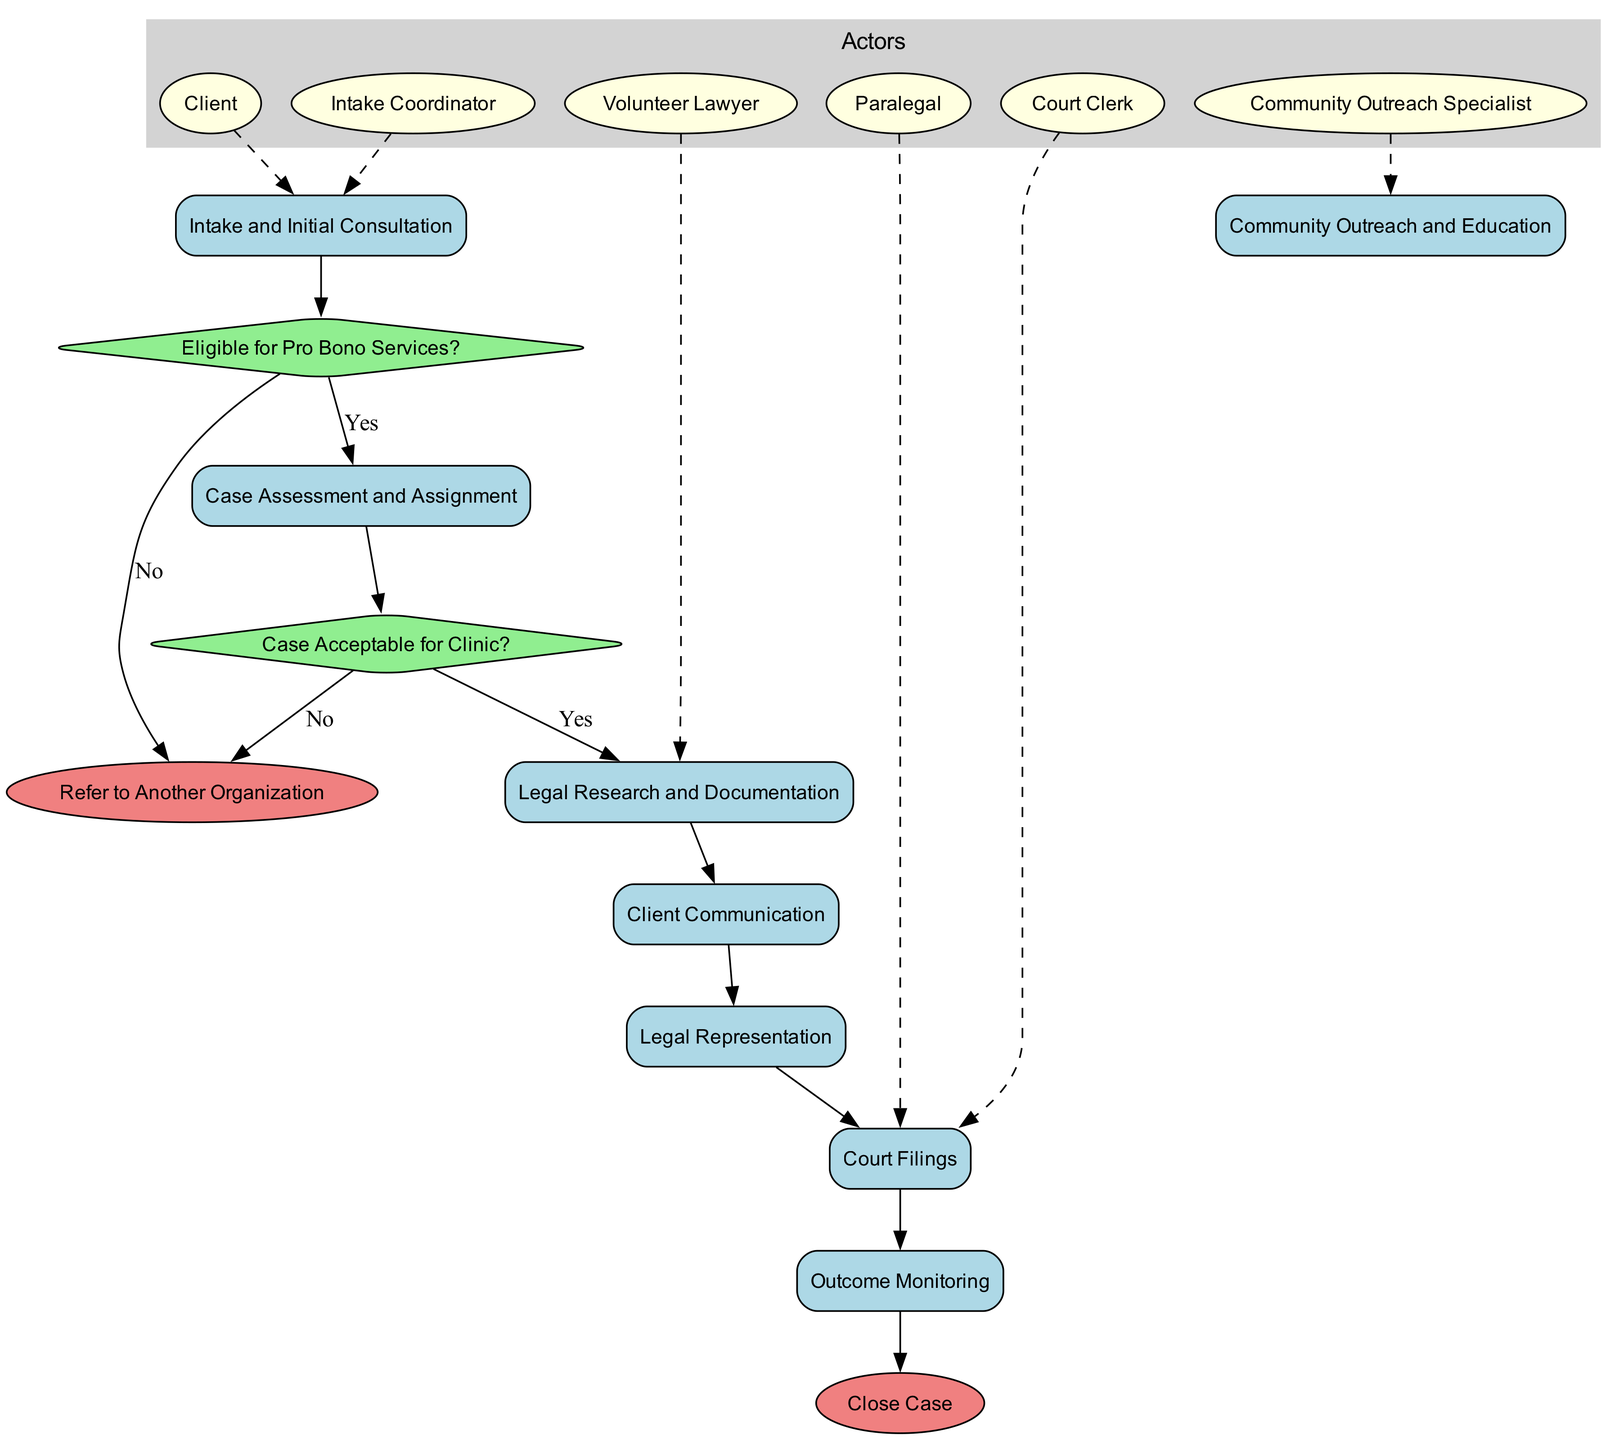What is the first activity in the diagram? The diagram lists "Intake and Initial Consultation" as the first activity, which is linked to the decision on eligibility for pro bono services.
Answer: Intake and Initial Consultation How many activities are shown in the diagram? The diagram presents a total of eight activities, all of which are listed under activities in the data.
Answer: 8 What is the last endpoint in the process? The last endpoint listed in the diagram is "Close Case," which follows the completion of the monitoring process.
Answer: Close Case Which actor is connected to "Legal Research and Documentation"? The diagram indicates that "Volunteer Lawyer" is connected to "Legal Research and Documentation" by a dashed line, indicating their involvement in this activity.
Answer: Volunteer Lawyer What happens if a case is not acceptable for the clinic? If a case is determined to be not acceptable, the flow leads to "Refer to Another Organization," indicating that the case will be referred elsewhere.
Answer: Refer to Another Organization What is the decision point after the case assessment? After the case assessment, the diagram shows the decision point "Case Acceptable for Clinic?" which evaluates the suitability of the case for the clinic's services.
Answer: Case Acceptable for Clinic? Which activities involve client communication? The flow of activities including "Client Communication" indicates that this is where direct communications with the client occur, which is crucial for the ongoing legal process.
Answer: Client Communication How many decisions are present in the diagram? The diagram displays two decision points, which assess eligibility for services and case acceptability for clinic representation.
Answer: 2 What is the primary role of the Community Outreach Specialist? The diagram connects "Community Outreach Specialist" to "Community Outreach and Education," indicating their role is focused on outreach efforts within the community.
Answer: Community Outreach and Education 